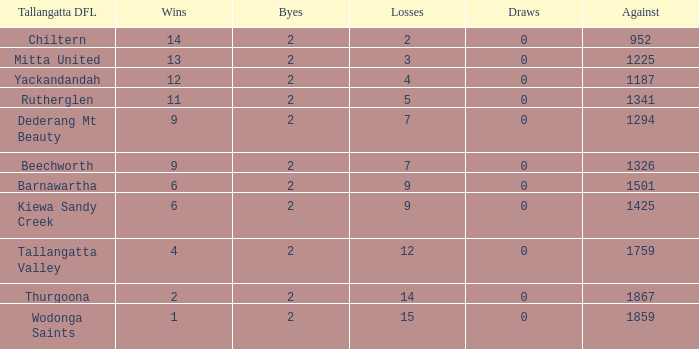What are the fewest draws with less than 7 losses and Mitta United is the Tallagatta DFL? 0.0. 